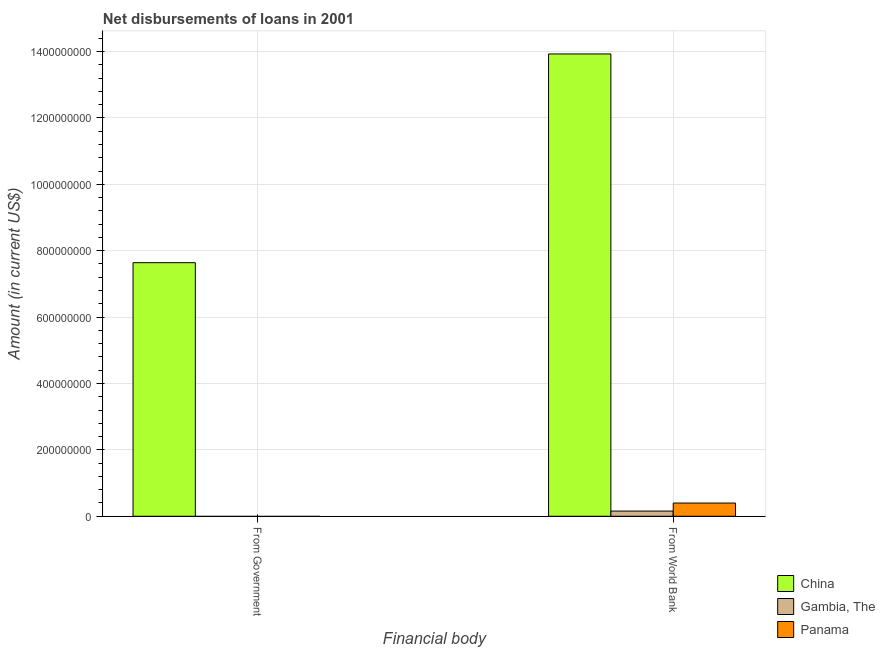How many different coloured bars are there?
Your response must be concise. 3. How many bars are there on the 1st tick from the left?
Provide a succinct answer. 1. What is the label of the 2nd group of bars from the left?
Ensure brevity in your answer.  From World Bank. What is the net disbursements of loan from government in China?
Give a very brief answer. 7.64e+08. Across all countries, what is the maximum net disbursements of loan from world bank?
Give a very brief answer. 1.39e+09. Across all countries, what is the minimum net disbursements of loan from government?
Offer a very short reply. 0. In which country was the net disbursements of loan from world bank maximum?
Provide a short and direct response. China. What is the total net disbursements of loan from government in the graph?
Ensure brevity in your answer.  7.64e+08. What is the difference between the net disbursements of loan from world bank in China and that in Gambia, The?
Give a very brief answer. 1.38e+09. What is the difference between the net disbursements of loan from government in China and the net disbursements of loan from world bank in Gambia, The?
Provide a short and direct response. 7.48e+08. What is the average net disbursements of loan from government per country?
Ensure brevity in your answer.  2.55e+08. What is the difference between the net disbursements of loan from world bank and net disbursements of loan from government in China?
Your response must be concise. 6.29e+08. What is the ratio of the net disbursements of loan from world bank in Panama to that in Gambia, The?
Make the answer very short. 2.55. Is the net disbursements of loan from world bank in Gambia, The less than that in Panama?
Your response must be concise. Yes. How many bars are there?
Offer a terse response. 4. How many countries are there in the graph?
Your answer should be very brief. 3. What is the difference between two consecutive major ticks on the Y-axis?
Give a very brief answer. 2.00e+08. Are the values on the major ticks of Y-axis written in scientific E-notation?
Give a very brief answer. No. Does the graph contain any zero values?
Make the answer very short. Yes. Does the graph contain grids?
Provide a short and direct response. Yes. What is the title of the graph?
Offer a terse response. Net disbursements of loans in 2001. What is the label or title of the X-axis?
Make the answer very short. Financial body. What is the Amount (in current US$) in China in From Government?
Your answer should be very brief. 7.64e+08. What is the Amount (in current US$) of Panama in From Government?
Give a very brief answer. 0. What is the Amount (in current US$) in China in From World Bank?
Your answer should be very brief. 1.39e+09. What is the Amount (in current US$) of Gambia, The in From World Bank?
Your answer should be compact. 1.56e+07. What is the Amount (in current US$) of Panama in From World Bank?
Your answer should be very brief. 3.98e+07. Across all Financial body, what is the maximum Amount (in current US$) of China?
Offer a terse response. 1.39e+09. Across all Financial body, what is the maximum Amount (in current US$) in Gambia, The?
Keep it short and to the point. 1.56e+07. Across all Financial body, what is the maximum Amount (in current US$) of Panama?
Provide a succinct answer. 3.98e+07. Across all Financial body, what is the minimum Amount (in current US$) in China?
Give a very brief answer. 7.64e+08. What is the total Amount (in current US$) in China in the graph?
Give a very brief answer. 2.16e+09. What is the total Amount (in current US$) in Gambia, The in the graph?
Your response must be concise. 1.56e+07. What is the total Amount (in current US$) of Panama in the graph?
Your answer should be very brief. 3.98e+07. What is the difference between the Amount (in current US$) of China in From Government and that in From World Bank?
Make the answer very short. -6.29e+08. What is the difference between the Amount (in current US$) of China in From Government and the Amount (in current US$) of Gambia, The in From World Bank?
Provide a short and direct response. 7.48e+08. What is the difference between the Amount (in current US$) of China in From Government and the Amount (in current US$) of Panama in From World Bank?
Make the answer very short. 7.24e+08. What is the average Amount (in current US$) of China per Financial body?
Ensure brevity in your answer.  1.08e+09. What is the average Amount (in current US$) of Gambia, The per Financial body?
Give a very brief answer. 7.80e+06. What is the average Amount (in current US$) of Panama per Financial body?
Keep it short and to the point. 1.99e+07. What is the difference between the Amount (in current US$) of China and Amount (in current US$) of Gambia, The in From World Bank?
Provide a short and direct response. 1.38e+09. What is the difference between the Amount (in current US$) of China and Amount (in current US$) of Panama in From World Bank?
Offer a very short reply. 1.35e+09. What is the difference between the Amount (in current US$) in Gambia, The and Amount (in current US$) in Panama in From World Bank?
Offer a very short reply. -2.42e+07. What is the ratio of the Amount (in current US$) of China in From Government to that in From World Bank?
Your response must be concise. 0.55. What is the difference between the highest and the second highest Amount (in current US$) in China?
Provide a succinct answer. 6.29e+08. What is the difference between the highest and the lowest Amount (in current US$) in China?
Your answer should be compact. 6.29e+08. What is the difference between the highest and the lowest Amount (in current US$) in Gambia, The?
Offer a terse response. 1.56e+07. What is the difference between the highest and the lowest Amount (in current US$) of Panama?
Offer a very short reply. 3.98e+07. 